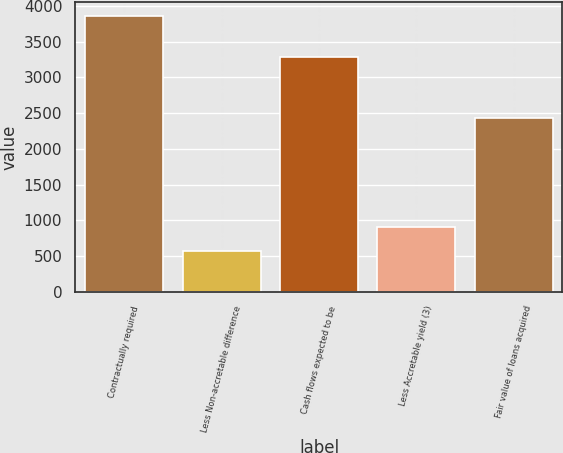Convert chart. <chart><loc_0><loc_0><loc_500><loc_500><bar_chart><fcel>Contractually required<fcel>Less Non-accretable difference<fcel>Cash flows expected to be<fcel>Less Accretable yield (3)<fcel>Fair value of loans acquired<nl><fcel>3861<fcel>573<fcel>3288<fcel>901.8<fcel>2433<nl></chart> 